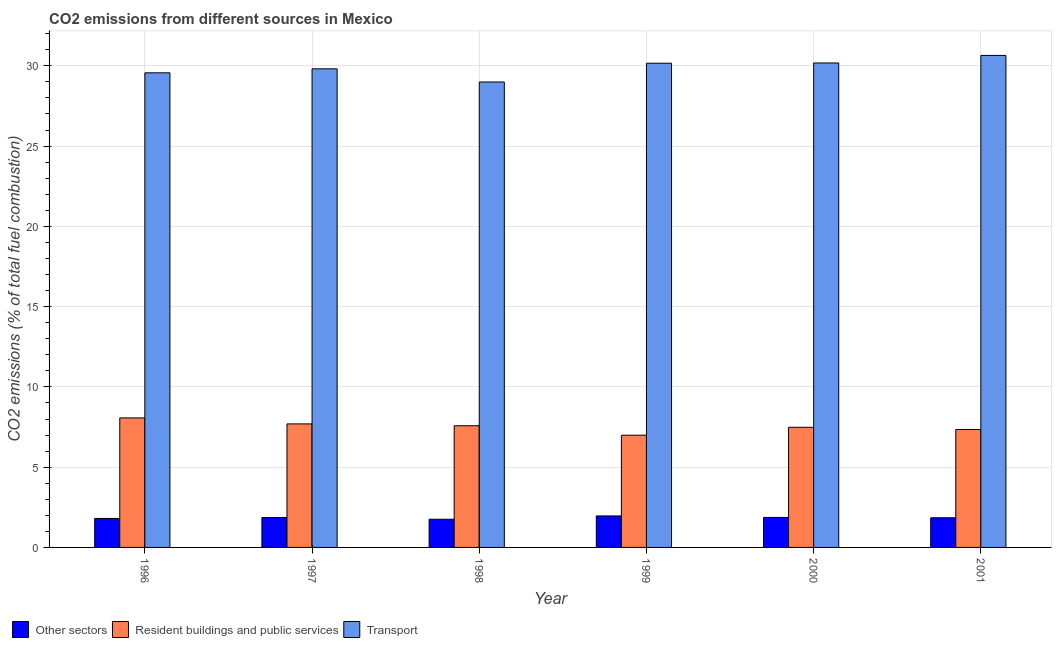How many different coloured bars are there?
Your answer should be compact. 3. How many bars are there on the 2nd tick from the left?
Provide a short and direct response. 3. How many bars are there on the 3rd tick from the right?
Provide a short and direct response. 3. What is the label of the 5th group of bars from the left?
Provide a short and direct response. 2000. In how many cases, is the number of bars for a given year not equal to the number of legend labels?
Provide a short and direct response. 0. What is the percentage of co2 emissions from resident buildings and public services in 1998?
Your answer should be very brief. 7.58. Across all years, what is the maximum percentage of co2 emissions from resident buildings and public services?
Your answer should be compact. 8.07. Across all years, what is the minimum percentage of co2 emissions from transport?
Offer a very short reply. 28.99. What is the total percentage of co2 emissions from transport in the graph?
Your answer should be very brief. 179.36. What is the difference between the percentage of co2 emissions from other sectors in 1997 and that in 1999?
Your answer should be very brief. -0.1. What is the difference between the percentage of co2 emissions from transport in 1999 and the percentage of co2 emissions from other sectors in 1996?
Ensure brevity in your answer.  0.6. What is the average percentage of co2 emissions from other sectors per year?
Offer a terse response. 1.85. In the year 1999, what is the difference between the percentage of co2 emissions from transport and percentage of co2 emissions from resident buildings and public services?
Make the answer very short. 0. What is the ratio of the percentage of co2 emissions from transport in 1998 to that in 1999?
Ensure brevity in your answer.  0.96. What is the difference between the highest and the second highest percentage of co2 emissions from other sectors?
Keep it short and to the point. 0.09. What is the difference between the highest and the lowest percentage of co2 emissions from transport?
Offer a terse response. 1.66. What does the 3rd bar from the left in 2001 represents?
Give a very brief answer. Transport. What does the 1st bar from the right in 1998 represents?
Offer a terse response. Transport. What is the difference between two consecutive major ticks on the Y-axis?
Provide a short and direct response. 5. Does the graph contain grids?
Make the answer very short. Yes. How many legend labels are there?
Keep it short and to the point. 3. How are the legend labels stacked?
Ensure brevity in your answer.  Horizontal. What is the title of the graph?
Ensure brevity in your answer.  CO2 emissions from different sources in Mexico. What is the label or title of the Y-axis?
Your answer should be very brief. CO2 emissions (% of total fuel combustion). What is the CO2 emissions (% of total fuel combustion) of Other sectors in 1996?
Offer a very short reply. 1.81. What is the CO2 emissions (% of total fuel combustion) of Resident buildings and public services in 1996?
Ensure brevity in your answer.  8.07. What is the CO2 emissions (% of total fuel combustion) of Transport in 1996?
Ensure brevity in your answer.  29.57. What is the CO2 emissions (% of total fuel combustion) in Other sectors in 1997?
Your response must be concise. 1.86. What is the CO2 emissions (% of total fuel combustion) of Resident buildings and public services in 1997?
Ensure brevity in your answer.  7.69. What is the CO2 emissions (% of total fuel combustion) in Transport in 1997?
Your answer should be very brief. 29.81. What is the CO2 emissions (% of total fuel combustion) in Other sectors in 1998?
Make the answer very short. 1.76. What is the CO2 emissions (% of total fuel combustion) in Resident buildings and public services in 1998?
Your response must be concise. 7.58. What is the CO2 emissions (% of total fuel combustion) in Transport in 1998?
Make the answer very short. 28.99. What is the CO2 emissions (% of total fuel combustion) of Other sectors in 1999?
Make the answer very short. 1.96. What is the CO2 emissions (% of total fuel combustion) in Resident buildings and public services in 1999?
Your answer should be very brief. 6.99. What is the CO2 emissions (% of total fuel combustion) in Transport in 1999?
Offer a very short reply. 30.16. What is the CO2 emissions (% of total fuel combustion) of Other sectors in 2000?
Make the answer very short. 1.87. What is the CO2 emissions (% of total fuel combustion) of Resident buildings and public services in 2000?
Offer a very short reply. 7.48. What is the CO2 emissions (% of total fuel combustion) in Transport in 2000?
Your answer should be compact. 30.18. What is the CO2 emissions (% of total fuel combustion) in Other sectors in 2001?
Your answer should be compact. 1.85. What is the CO2 emissions (% of total fuel combustion) in Resident buildings and public services in 2001?
Keep it short and to the point. 7.35. What is the CO2 emissions (% of total fuel combustion) of Transport in 2001?
Make the answer very short. 30.65. Across all years, what is the maximum CO2 emissions (% of total fuel combustion) in Other sectors?
Keep it short and to the point. 1.96. Across all years, what is the maximum CO2 emissions (% of total fuel combustion) of Resident buildings and public services?
Make the answer very short. 8.07. Across all years, what is the maximum CO2 emissions (% of total fuel combustion) of Transport?
Provide a short and direct response. 30.65. Across all years, what is the minimum CO2 emissions (% of total fuel combustion) of Other sectors?
Your answer should be very brief. 1.76. Across all years, what is the minimum CO2 emissions (% of total fuel combustion) of Resident buildings and public services?
Offer a terse response. 6.99. Across all years, what is the minimum CO2 emissions (% of total fuel combustion) of Transport?
Provide a succinct answer. 28.99. What is the total CO2 emissions (% of total fuel combustion) of Other sectors in the graph?
Your response must be concise. 11.1. What is the total CO2 emissions (% of total fuel combustion) of Resident buildings and public services in the graph?
Offer a terse response. 45.16. What is the total CO2 emissions (% of total fuel combustion) in Transport in the graph?
Your response must be concise. 179.36. What is the difference between the CO2 emissions (% of total fuel combustion) of Other sectors in 1996 and that in 1997?
Your answer should be very brief. -0.06. What is the difference between the CO2 emissions (% of total fuel combustion) in Resident buildings and public services in 1996 and that in 1997?
Ensure brevity in your answer.  0.37. What is the difference between the CO2 emissions (% of total fuel combustion) of Transport in 1996 and that in 1997?
Provide a short and direct response. -0.25. What is the difference between the CO2 emissions (% of total fuel combustion) of Other sectors in 1996 and that in 1998?
Your answer should be compact. 0.05. What is the difference between the CO2 emissions (% of total fuel combustion) of Resident buildings and public services in 1996 and that in 1998?
Offer a very short reply. 0.49. What is the difference between the CO2 emissions (% of total fuel combustion) in Transport in 1996 and that in 1998?
Give a very brief answer. 0.57. What is the difference between the CO2 emissions (% of total fuel combustion) of Other sectors in 1996 and that in 1999?
Ensure brevity in your answer.  -0.16. What is the difference between the CO2 emissions (% of total fuel combustion) in Resident buildings and public services in 1996 and that in 1999?
Keep it short and to the point. 1.08. What is the difference between the CO2 emissions (% of total fuel combustion) in Transport in 1996 and that in 1999?
Offer a terse response. -0.6. What is the difference between the CO2 emissions (% of total fuel combustion) of Other sectors in 1996 and that in 2000?
Your response must be concise. -0.06. What is the difference between the CO2 emissions (% of total fuel combustion) in Resident buildings and public services in 1996 and that in 2000?
Your response must be concise. 0.58. What is the difference between the CO2 emissions (% of total fuel combustion) of Transport in 1996 and that in 2000?
Your answer should be compact. -0.61. What is the difference between the CO2 emissions (% of total fuel combustion) of Other sectors in 1996 and that in 2001?
Offer a terse response. -0.04. What is the difference between the CO2 emissions (% of total fuel combustion) in Resident buildings and public services in 1996 and that in 2001?
Your answer should be compact. 0.72. What is the difference between the CO2 emissions (% of total fuel combustion) of Transport in 1996 and that in 2001?
Your answer should be very brief. -1.08. What is the difference between the CO2 emissions (% of total fuel combustion) of Other sectors in 1997 and that in 1998?
Provide a short and direct response. 0.11. What is the difference between the CO2 emissions (% of total fuel combustion) in Resident buildings and public services in 1997 and that in 1998?
Ensure brevity in your answer.  0.11. What is the difference between the CO2 emissions (% of total fuel combustion) in Transport in 1997 and that in 1998?
Keep it short and to the point. 0.82. What is the difference between the CO2 emissions (% of total fuel combustion) of Other sectors in 1997 and that in 1999?
Your answer should be very brief. -0.1. What is the difference between the CO2 emissions (% of total fuel combustion) in Resident buildings and public services in 1997 and that in 1999?
Your answer should be very brief. 0.7. What is the difference between the CO2 emissions (% of total fuel combustion) of Transport in 1997 and that in 1999?
Provide a short and direct response. -0.35. What is the difference between the CO2 emissions (% of total fuel combustion) in Other sectors in 1997 and that in 2000?
Give a very brief answer. -0. What is the difference between the CO2 emissions (% of total fuel combustion) in Resident buildings and public services in 1997 and that in 2000?
Make the answer very short. 0.21. What is the difference between the CO2 emissions (% of total fuel combustion) in Transport in 1997 and that in 2000?
Offer a very short reply. -0.37. What is the difference between the CO2 emissions (% of total fuel combustion) in Other sectors in 1997 and that in 2001?
Ensure brevity in your answer.  0.02. What is the difference between the CO2 emissions (% of total fuel combustion) in Resident buildings and public services in 1997 and that in 2001?
Provide a short and direct response. 0.35. What is the difference between the CO2 emissions (% of total fuel combustion) in Transport in 1997 and that in 2001?
Give a very brief answer. -0.84. What is the difference between the CO2 emissions (% of total fuel combustion) of Other sectors in 1998 and that in 1999?
Offer a terse response. -0.21. What is the difference between the CO2 emissions (% of total fuel combustion) of Resident buildings and public services in 1998 and that in 1999?
Give a very brief answer. 0.59. What is the difference between the CO2 emissions (% of total fuel combustion) of Transport in 1998 and that in 1999?
Offer a terse response. -1.17. What is the difference between the CO2 emissions (% of total fuel combustion) of Other sectors in 1998 and that in 2000?
Your answer should be compact. -0.11. What is the difference between the CO2 emissions (% of total fuel combustion) of Resident buildings and public services in 1998 and that in 2000?
Provide a short and direct response. 0.1. What is the difference between the CO2 emissions (% of total fuel combustion) of Transport in 1998 and that in 2000?
Offer a very short reply. -1.19. What is the difference between the CO2 emissions (% of total fuel combustion) of Other sectors in 1998 and that in 2001?
Your response must be concise. -0.09. What is the difference between the CO2 emissions (% of total fuel combustion) of Resident buildings and public services in 1998 and that in 2001?
Your response must be concise. 0.23. What is the difference between the CO2 emissions (% of total fuel combustion) of Transport in 1998 and that in 2001?
Keep it short and to the point. -1.66. What is the difference between the CO2 emissions (% of total fuel combustion) in Other sectors in 1999 and that in 2000?
Your answer should be compact. 0.09. What is the difference between the CO2 emissions (% of total fuel combustion) in Resident buildings and public services in 1999 and that in 2000?
Provide a short and direct response. -0.49. What is the difference between the CO2 emissions (% of total fuel combustion) in Transport in 1999 and that in 2000?
Make the answer very short. -0.02. What is the difference between the CO2 emissions (% of total fuel combustion) of Other sectors in 1999 and that in 2001?
Provide a succinct answer. 0.11. What is the difference between the CO2 emissions (% of total fuel combustion) of Resident buildings and public services in 1999 and that in 2001?
Give a very brief answer. -0.36. What is the difference between the CO2 emissions (% of total fuel combustion) in Transport in 1999 and that in 2001?
Provide a short and direct response. -0.49. What is the difference between the CO2 emissions (% of total fuel combustion) in Other sectors in 2000 and that in 2001?
Keep it short and to the point. 0.02. What is the difference between the CO2 emissions (% of total fuel combustion) in Resident buildings and public services in 2000 and that in 2001?
Your answer should be very brief. 0.14. What is the difference between the CO2 emissions (% of total fuel combustion) of Transport in 2000 and that in 2001?
Offer a terse response. -0.47. What is the difference between the CO2 emissions (% of total fuel combustion) of Other sectors in 1996 and the CO2 emissions (% of total fuel combustion) of Resident buildings and public services in 1997?
Your response must be concise. -5.89. What is the difference between the CO2 emissions (% of total fuel combustion) of Other sectors in 1996 and the CO2 emissions (% of total fuel combustion) of Transport in 1997?
Your response must be concise. -28.01. What is the difference between the CO2 emissions (% of total fuel combustion) of Resident buildings and public services in 1996 and the CO2 emissions (% of total fuel combustion) of Transport in 1997?
Your answer should be compact. -21.75. What is the difference between the CO2 emissions (% of total fuel combustion) in Other sectors in 1996 and the CO2 emissions (% of total fuel combustion) in Resident buildings and public services in 1998?
Your answer should be very brief. -5.77. What is the difference between the CO2 emissions (% of total fuel combustion) in Other sectors in 1996 and the CO2 emissions (% of total fuel combustion) in Transport in 1998?
Ensure brevity in your answer.  -27.19. What is the difference between the CO2 emissions (% of total fuel combustion) in Resident buildings and public services in 1996 and the CO2 emissions (% of total fuel combustion) in Transport in 1998?
Make the answer very short. -20.93. What is the difference between the CO2 emissions (% of total fuel combustion) in Other sectors in 1996 and the CO2 emissions (% of total fuel combustion) in Resident buildings and public services in 1999?
Your answer should be very brief. -5.18. What is the difference between the CO2 emissions (% of total fuel combustion) in Other sectors in 1996 and the CO2 emissions (% of total fuel combustion) in Transport in 1999?
Make the answer very short. -28.36. What is the difference between the CO2 emissions (% of total fuel combustion) of Resident buildings and public services in 1996 and the CO2 emissions (% of total fuel combustion) of Transport in 1999?
Make the answer very short. -22.09. What is the difference between the CO2 emissions (% of total fuel combustion) of Other sectors in 1996 and the CO2 emissions (% of total fuel combustion) of Resident buildings and public services in 2000?
Ensure brevity in your answer.  -5.68. What is the difference between the CO2 emissions (% of total fuel combustion) in Other sectors in 1996 and the CO2 emissions (% of total fuel combustion) in Transport in 2000?
Ensure brevity in your answer.  -28.37. What is the difference between the CO2 emissions (% of total fuel combustion) in Resident buildings and public services in 1996 and the CO2 emissions (% of total fuel combustion) in Transport in 2000?
Give a very brief answer. -22.11. What is the difference between the CO2 emissions (% of total fuel combustion) in Other sectors in 1996 and the CO2 emissions (% of total fuel combustion) in Resident buildings and public services in 2001?
Your answer should be very brief. -5.54. What is the difference between the CO2 emissions (% of total fuel combustion) of Other sectors in 1996 and the CO2 emissions (% of total fuel combustion) of Transport in 2001?
Your answer should be compact. -28.84. What is the difference between the CO2 emissions (% of total fuel combustion) of Resident buildings and public services in 1996 and the CO2 emissions (% of total fuel combustion) of Transport in 2001?
Your answer should be compact. -22.58. What is the difference between the CO2 emissions (% of total fuel combustion) in Other sectors in 1997 and the CO2 emissions (% of total fuel combustion) in Resident buildings and public services in 1998?
Your answer should be compact. -5.72. What is the difference between the CO2 emissions (% of total fuel combustion) in Other sectors in 1997 and the CO2 emissions (% of total fuel combustion) in Transport in 1998?
Offer a terse response. -27.13. What is the difference between the CO2 emissions (% of total fuel combustion) in Resident buildings and public services in 1997 and the CO2 emissions (% of total fuel combustion) in Transport in 1998?
Provide a succinct answer. -21.3. What is the difference between the CO2 emissions (% of total fuel combustion) in Other sectors in 1997 and the CO2 emissions (% of total fuel combustion) in Resident buildings and public services in 1999?
Offer a terse response. -5.13. What is the difference between the CO2 emissions (% of total fuel combustion) in Other sectors in 1997 and the CO2 emissions (% of total fuel combustion) in Transport in 1999?
Your answer should be compact. -28.3. What is the difference between the CO2 emissions (% of total fuel combustion) of Resident buildings and public services in 1997 and the CO2 emissions (% of total fuel combustion) of Transport in 1999?
Make the answer very short. -22.47. What is the difference between the CO2 emissions (% of total fuel combustion) of Other sectors in 1997 and the CO2 emissions (% of total fuel combustion) of Resident buildings and public services in 2000?
Ensure brevity in your answer.  -5.62. What is the difference between the CO2 emissions (% of total fuel combustion) in Other sectors in 1997 and the CO2 emissions (% of total fuel combustion) in Transport in 2000?
Ensure brevity in your answer.  -28.31. What is the difference between the CO2 emissions (% of total fuel combustion) of Resident buildings and public services in 1997 and the CO2 emissions (% of total fuel combustion) of Transport in 2000?
Make the answer very short. -22.48. What is the difference between the CO2 emissions (% of total fuel combustion) in Other sectors in 1997 and the CO2 emissions (% of total fuel combustion) in Resident buildings and public services in 2001?
Offer a terse response. -5.48. What is the difference between the CO2 emissions (% of total fuel combustion) in Other sectors in 1997 and the CO2 emissions (% of total fuel combustion) in Transport in 2001?
Provide a short and direct response. -28.78. What is the difference between the CO2 emissions (% of total fuel combustion) of Resident buildings and public services in 1997 and the CO2 emissions (% of total fuel combustion) of Transport in 2001?
Ensure brevity in your answer.  -22.95. What is the difference between the CO2 emissions (% of total fuel combustion) of Other sectors in 1998 and the CO2 emissions (% of total fuel combustion) of Resident buildings and public services in 1999?
Your answer should be very brief. -5.23. What is the difference between the CO2 emissions (% of total fuel combustion) of Other sectors in 1998 and the CO2 emissions (% of total fuel combustion) of Transport in 1999?
Your answer should be very brief. -28.41. What is the difference between the CO2 emissions (% of total fuel combustion) in Resident buildings and public services in 1998 and the CO2 emissions (% of total fuel combustion) in Transport in 1999?
Offer a very short reply. -22.58. What is the difference between the CO2 emissions (% of total fuel combustion) in Other sectors in 1998 and the CO2 emissions (% of total fuel combustion) in Resident buildings and public services in 2000?
Your answer should be compact. -5.73. What is the difference between the CO2 emissions (% of total fuel combustion) in Other sectors in 1998 and the CO2 emissions (% of total fuel combustion) in Transport in 2000?
Keep it short and to the point. -28.42. What is the difference between the CO2 emissions (% of total fuel combustion) in Resident buildings and public services in 1998 and the CO2 emissions (% of total fuel combustion) in Transport in 2000?
Ensure brevity in your answer.  -22.6. What is the difference between the CO2 emissions (% of total fuel combustion) of Other sectors in 1998 and the CO2 emissions (% of total fuel combustion) of Resident buildings and public services in 2001?
Make the answer very short. -5.59. What is the difference between the CO2 emissions (% of total fuel combustion) of Other sectors in 1998 and the CO2 emissions (% of total fuel combustion) of Transport in 2001?
Offer a terse response. -28.89. What is the difference between the CO2 emissions (% of total fuel combustion) of Resident buildings and public services in 1998 and the CO2 emissions (% of total fuel combustion) of Transport in 2001?
Offer a very short reply. -23.07. What is the difference between the CO2 emissions (% of total fuel combustion) of Other sectors in 1999 and the CO2 emissions (% of total fuel combustion) of Resident buildings and public services in 2000?
Offer a very short reply. -5.52. What is the difference between the CO2 emissions (% of total fuel combustion) of Other sectors in 1999 and the CO2 emissions (% of total fuel combustion) of Transport in 2000?
Your response must be concise. -28.22. What is the difference between the CO2 emissions (% of total fuel combustion) in Resident buildings and public services in 1999 and the CO2 emissions (% of total fuel combustion) in Transport in 2000?
Offer a very short reply. -23.19. What is the difference between the CO2 emissions (% of total fuel combustion) in Other sectors in 1999 and the CO2 emissions (% of total fuel combustion) in Resident buildings and public services in 2001?
Give a very brief answer. -5.38. What is the difference between the CO2 emissions (% of total fuel combustion) in Other sectors in 1999 and the CO2 emissions (% of total fuel combustion) in Transport in 2001?
Keep it short and to the point. -28.69. What is the difference between the CO2 emissions (% of total fuel combustion) in Resident buildings and public services in 1999 and the CO2 emissions (% of total fuel combustion) in Transport in 2001?
Your answer should be compact. -23.66. What is the difference between the CO2 emissions (% of total fuel combustion) of Other sectors in 2000 and the CO2 emissions (% of total fuel combustion) of Resident buildings and public services in 2001?
Offer a terse response. -5.48. What is the difference between the CO2 emissions (% of total fuel combustion) in Other sectors in 2000 and the CO2 emissions (% of total fuel combustion) in Transport in 2001?
Your answer should be compact. -28.78. What is the difference between the CO2 emissions (% of total fuel combustion) in Resident buildings and public services in 2000 and the CO2 emissions (% of total fuel combustion) in Transport in 2001?
Provide a succinct answer. -23.16. What is the average CO2 emissions (% of total fuel combustion) of Other sectors per year?
Keep it short and to the point. 1.85. What is the average CO2 emissions (% of total fuel combustion) of Resident buildings and public services per year?
Make the answer very short. 7.53. What is the average CO2 emissions (% of total fuel combustion) of Transport per year?
Ensure brevity in your answer.  29.89. In the year 1996, what is the difference between the CO2 emissions (% of total fuel combustion) of Other sectors and CO2 emissions (% of total fuel combustion) of Resident buildings and public services?
Keep it short and to the point. -6.26. In the year 1996, what is the difference between the CO2 emissions (% of total fuel combustion) in Other sectors and CO2 emissions (% of total fuel combustion) in Transport?
Give a very brief answer. -27.76. In the year 1996, what is the difference between the CO2 emissions (% of total fuel combustion) of Resident buildings and public services and CO2 emissions (% of total fuel combustion) of Transport?
Ensure brevity in your answer.  -21.5. In the year 1997, what is the difference between the CO2 emissions (% of total fuel combustion) of Other sectors and CO2 emissions (% of total fuel combustion) of Resident buildings and public services?
Give a very brief answer. -5.83. In the year 1997, what is the difference between the CO2 emissions (% of total fuel combustion) of Other sectors and CO2 emissions (% of total fuel combustion) of Transport?
Give a very brief answer. -27.95. In the year 1997, what is the difference between the CO2 emissions (% of total fuel combustion) of Resident buildings and public services and CO2 emissions (% of total fuel combustion) of Transport?
Offer a very short reply. -22.12. In the year 1998, what is the difference between the CO2 emissions (% of total fuel combustion) of Other sectors and CO2 emissions (% of total fuel combustion) of Resident buildings and public services?
Ensure brevity in your answer.  -5.82. In the year 1998, what is the difference between the CO2 emissions (% of total fuel combustion) of Other sectors and CO2 emissions (% of total fuel combustion) of Transport?
Offer a very short reply. -27.24. In the year 1998, what is the difference between the CO2 emissions (% of total fuel combustion) in Resident buildings and public services and CO2 emissions (% of total fuel combustion) in Transport?
Make the answer very short. -21.41. In the year 1999, what is the difference between the CO2 emissions (% of total fuel combustion) in Other sectors and CO2 emissions (% of total fuel combustion) in Resident buildings and public services?
Your answer should be very brief. -5.03. In the year 1999, what is the difference between the CO2 emissions (% of total fuel combustion) in Other sectors and CO2 emissions (% of total fuel combustion) in Transport?
Your answer should be very brief. -28.2. In the year 1999, what is the difference between the CO2 emissions (% of total fuel combustion) in Resident buildings and public services and CO2 emissions (% of total fuel combustion) in Transport?
Your answer should be compact. -23.17. In the year 2000, what is the difference between the CO2 emissions (% of total fuel combustion) of Other sectors and CO2 emissions (% of total fuel combustion) of Resident buildings and public services?
Your answer should be very brief. -5.62. In the year 2000, what is the difference between the CO2 emissions (% of total fuel combustion) in Other sectors and CO2 emissions (% of total fuel combustion) in Transport?
Make the answer very short. -28.31. In the year 2000, what is the difference between the CO2 emissions (% of total fuel combustion) of Resident buildings and public services and CO2 emissions (% of total fuel combustion) of Transport?
Your answer should be very brief. -22.69. In the year 2001, what is the difference between the CO2 emissions (% of total fuel combustion) of Other sectors and CO2 emissions (% of total fuel combustion) of Resident buildings and public services?
Your answer should be very brief. -5.5. In the year 2001, what is the difference between the CO2 emissions (% of total fuel combustion) in Other sectors and CO2 emissions (% of total fuel combustion) in Transport?
Your response must be concise. -28.8. In the year 2001, what is the difference between the CO2 emissions (% of total fuel combustion) of Resident buildings and public services and CO2 emissions (% of total fuel combustion) of Transport?
Make the answer very short. -23.3. What is the ratio of the CO2 emissions (% of total fuel combustion) of Other sectors in 1996 to that in 1997?
Provide a short and direct response. 0.97. What is the ratio of the CO2 emissions (% of total fuel combustion) of Resident buildings and public services in 1996 to that in 1997?
Give a very brief answer. 1.05. What is the ratio of the CO2 emissions (% of total fuel combustion) in Other sectors in 1996 to that in 1998?
Offer a very short reply. 1.03. What is the ratio of the CO2 emissions (% of total fuel combustion) of Resident buildings and public services in 1996 to that in 1998?
Make the answer very short. 1.06. What is the ratio of the CO2 emissions (% of total fuel combustion) of Transport in 1996 to that in 1998?
Ensure brevity in your answer.  1.02. What is the ratio of the CO2 emissions (% of total fuel combustion) in Other sectors in 1996 to that in 1999?
Offer a terse response. 0.92. What is the ratio of the CO2 emissions (% of total fuel combustion) in Resident buildings and public services in 1996 to that in 1999?
Give a very brief answer. 1.15. What is the ratio of the CO2 emissions (% of total fuel combustion) of Transport in 1996 to that in 1999?
Provide a succinct answer. 0.98. What is the ratio of the CO2 emissions (% of total fuel combustion) of Other sectors in 1996 to that in 2000?
Your answer should be very brief. 0.97. What is the ratio of the CO2 emissions (% of total fuel combustion) in Resident buildings and public services in 1996 to that in 2000?
Offer a very short reply. 1.08. What is the ratio of the CO2 emissions (% of total fuel combustion) of Transport in 1996 to that in 2000?
Provide a short and direct response. 0.98. What is the ratio of the CO2 emissions (% of total fuel combustion) of Other sectors in 1996 to that in 2001?
Your response must be concise. 0.98. What is the ratio of the CO2 emissions (% of total fuel combustion) of Resident buildings and public services in 1996 to that in 2001?
Keep it short and to the point. 1.1. What is the ratio of the CO2 emissions (% of total fuel combustion) of Transport in 1996 to that in 2001?
Give a very brief answer. 0.96. What is the ratio of the CO2 emissions (% of total fuel combustion) in Other sectors in 1997 to that in 1998?
Give a very brief answer. 1.06. What is the ratio of the CO2 emissions (% of total fuel combustion) in Resident buildings and public services in 1997 to that in 1998?
Your answer should be very brief. 1.02. What is the ratio of the CO2 emissions (% of total fuel combustion) of Transport in 1997 to that in 1998?
Keep it short and to the point. 1.03. What is the ratio of the CO2 emissions (% of total fuel combustion) of Other sectors in 1997 to that in 1999?
Make the answer very short. 0.95. What is the ratio of the CO2 emissions (% of total fuel combustion) of Resident buildings and public services in 1997 to that in 1999?
Provide a succinct answer. 1.1. What is the ratio of the CO2 emissions (% of total fuel combustion) in Transport in 1997 to that in 1999?
Provide a short and direct response. 0.99. What is the ratio of the CO2 emissions (% of total fuel combustion) of Resident buildings and public services in 1997 to that in 2000?
Offer a terse response. 1.03. What is the ratio of the CO2 emissions (% of total fuel combustion) in Transport in 1997 to that in 2000?
Your response must be concise. 0.99. What is the ratio of the CO2 emissions (% of total fuel combustion) of Other sectors in 1997 to that in 2001?
Your response must be concise. 1.01. What is the ratio of the CO2 emissions (% of total fuel combustion) of Resident buildings and public services in 1997 to that in 2001?
Keep it short and to the point. 1.05. What is the ratio of the CO2 emissions (% of total fuel combustion) of Transport in 1997 to that in 2001?
Your response must be concise. 0.97. What is the ratio of the CO2 emissions (% of total fuel combustion) in Other sectors in 1998 to that in 1999?
Make the answer very short. 0.89. What is the ratio of the CO2 emissions (% of total fuel combustion) of Resident buildings and public services in 1998 to that in 1999?
Provide a succinct answer. 1.08. What is the ratio of the CO2 emissions (% of total fuel combustion) of Transport in 1998 to that in 1999?
Offer a very short reply. 0.96. What is the ratio of the CO2 emissions (% of total fuel combustion) of Other sectors in 1998 to that in 2000?
Your answer should be compact. 0.94. What is the ratio of the CO2 emissions (% of total fuel combustion) of Resident buildings and public services in 1998 to that in 2000?
Provide a succinct answer. 1.01. What is the ratio of the CO2 emissions (% of total fuel combustion) in Transport in 1998 to that in 2000?
Make the answer very short. 0.96. What is the ratio of the CO2 emissions (% of total fuel combustion) of Other sectors in 1998 to that in 2001?
Your answer should be very brief. 0.95. What is the ratio of the CO2 emissions (% of total fuel combustion) of Resident buildings and public services in 1998 to that in 2001?
Make the answer very short. 1.03. What is the ratio of the CO2 emissions (% of total fuel combustion) in Transport in 1998 to that in 2001?
Your response must be concise. 0.95. What is the ratio of the CO2 emissions (% of total fuel combustion) in Other sectors in 1999 to that in 2000?
Provide a short and direct response. 1.05. What is the ratio of the CO2 emissions (% of total fuel combustion) of Resident buildings and public services in 1999 to that in 2000?
Make the answer very short. 0.93. What is the ratio of the CO2 emissions (% of total fuel combustion) of Transport in 1999 to that in 2000?
Ensure brevity in your answer.  1. What is the ratio of the CO2 emissions (% of total fuel combustion) of Other sectors in 1999 to that in 2001?
Offer a terse response. 1.06. What is the ratio of the CO2 emissions (% of total fuel combustion) of Resident buildings and public services in 1999 to that in 2001?
Make the answer very short. 0.95. What is the ratio of the CO2 emissions (% of total fuel combustion) of Transport in 1999 to that in 2001?
Provide a short and direct response. 0.98. What is the ratio of the CO2 emissions (% of total fuel combustion) in Other sectors in 2000 to that in 2001?
Provide a succinct answer. 1.01. What is the ratio of the CO2 emissions (% of total fuel combustion) in Resident buildings and public services in 2000 to that in 2001?
Your answer should be compact. 1.02. What is the ratio of the CO2 emissions (% of total fuel combustion) in Transport in 2000 to that in 2001?
Your answer should be compact. 0.98. What is the difference between the highest and the second highest CO2 emissions (% of total fuel combustion) in Other sectors?
Make the answer very short. 0.09. What is the difference between the highest and the second highest CO2 emissions (% of total fuel combustion) of Resident buildings and public services?
Your answer should be compact. 0.37. What is the difference between the highest and the second highest CO2 emissions (% of total fuel combustion) in Transport?
Ensure brevity in your answer.  0.47. What is the difference between the highest and the lowest CO2 emissions (% of total fuel combustion) of Other sectors?
Keep it short and to the point. 0.21. What is the difference between the highest and the lowest CO2 emissions (% of total fuel combustion) of Resident buildings and public services?
Your answer should be compact. 1.08. What is the difference between the highest and the lowest CO2 emissions (% of total fuel combustion) in Transport?
Your response must be concise. 1.66. 